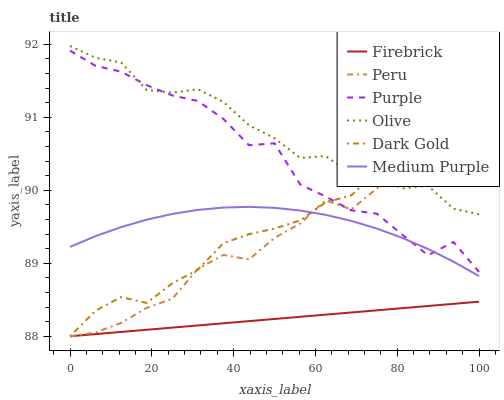Does Firebrick have the minimum area under the curve?
Answer yes or no. Yes. Does Olive have the maximum area under the curve?
Answer yes or no. Yes. Does Purple have the minimum area under the curve?
Answer yes or no. No. Does Purple have the maximum area under the curve?
Answer yes or no. No. Is Firebrick the smoothest?
Answer yes or no. Yes. Is Peru the roughest?
Answer yes or no. Yes. Is Purple the smoothest?
Answer yes or no. No. Is Purple the roughest?
Answer yes or no. No. Does Purple have the lowest value?
Answer yes or no. No. Does Olive have the highest value?
Answer yes or no. Yes. Does Purple have the highest value?
Answer yes or no. No. Is Firebrick less than Medium Purple?
Answer yes or no. Yes. Is Medium Purple greater than Firebrick?
Answer yes or no. Yes. Does Dark Gold intersect Firebrick?
Answer yes or no. Yes. Is Dark Gold less than Firebrick?
Answer yes or no. No. Is Dark Gold greater than Firebrick?
Answer yes or no. No. Does Firebrick intersect Medium Purple?
Answer yes or no. No. 